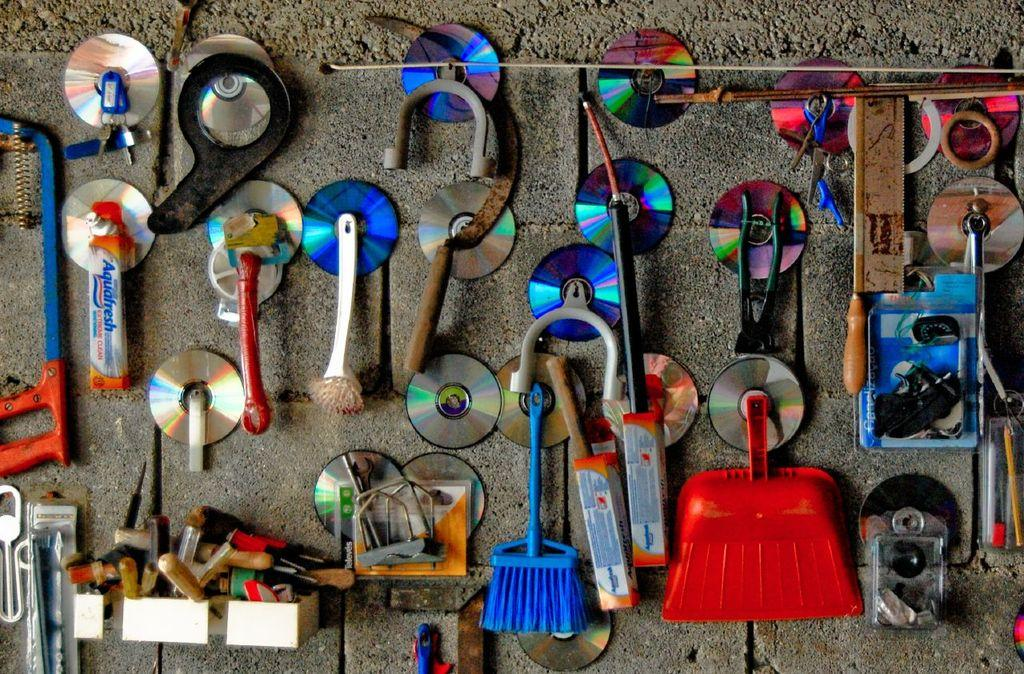What type of objects can be seen in the image? There are CD Discs in the image. Are there any other items visible in the image? Yes, there are other tools attached to the wall in the image. What type of crime is being committed in the image? There is no crime being committed in the image; it only shows CD Discs and tools attached to the wall. Can you describe the tank that is visible in the image? There is no tank present in the image. 